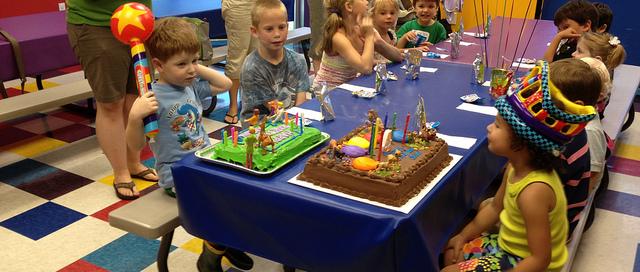How many cakes on the table?
Concise answer only. 2. Is this a big Christmas party?
Give a very brief answer. No. What sort of celebration is this?
Keep it brief. Birthday. 